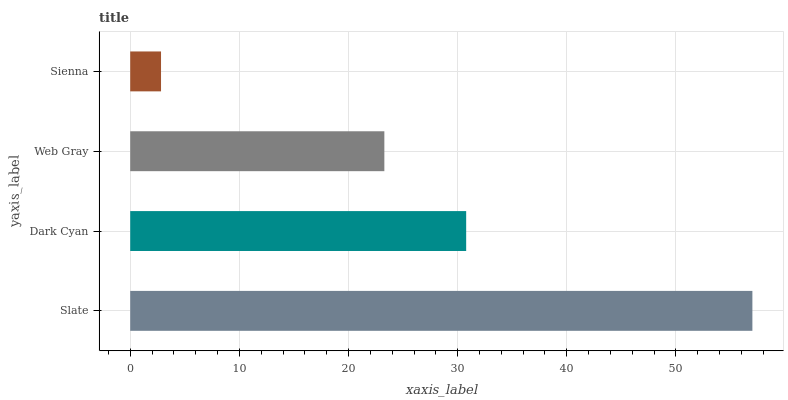Is Sienna the minimum?
Answer yes or no. Yes. Is Slate the maximum?
Answer yes or no. Yes. Is Dark Cyan the minimum?
Answer yes or no. No. Is Dark Cyan the maximum?
Answer yes or no. No. Is Slate greater than Dark Cyan?
Answer yes or no. Yes. Is Dark Cyan less than Slate?
Answer yes or no. Yes. Is Dark Cyan greater than Slate?
Answer yes or no. No. Is Slate less than Dark Cyan?
Answer yes or no. No. Is Dark Cyan the high median?
Answer yes or no. Yes. Is Web Gray the low median?
Answer yes or no. Yes. Is Web Gray the high median?
Answer yes or no. No. Is Slate the low median?
Answer yes or no. No. 